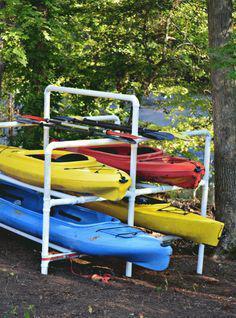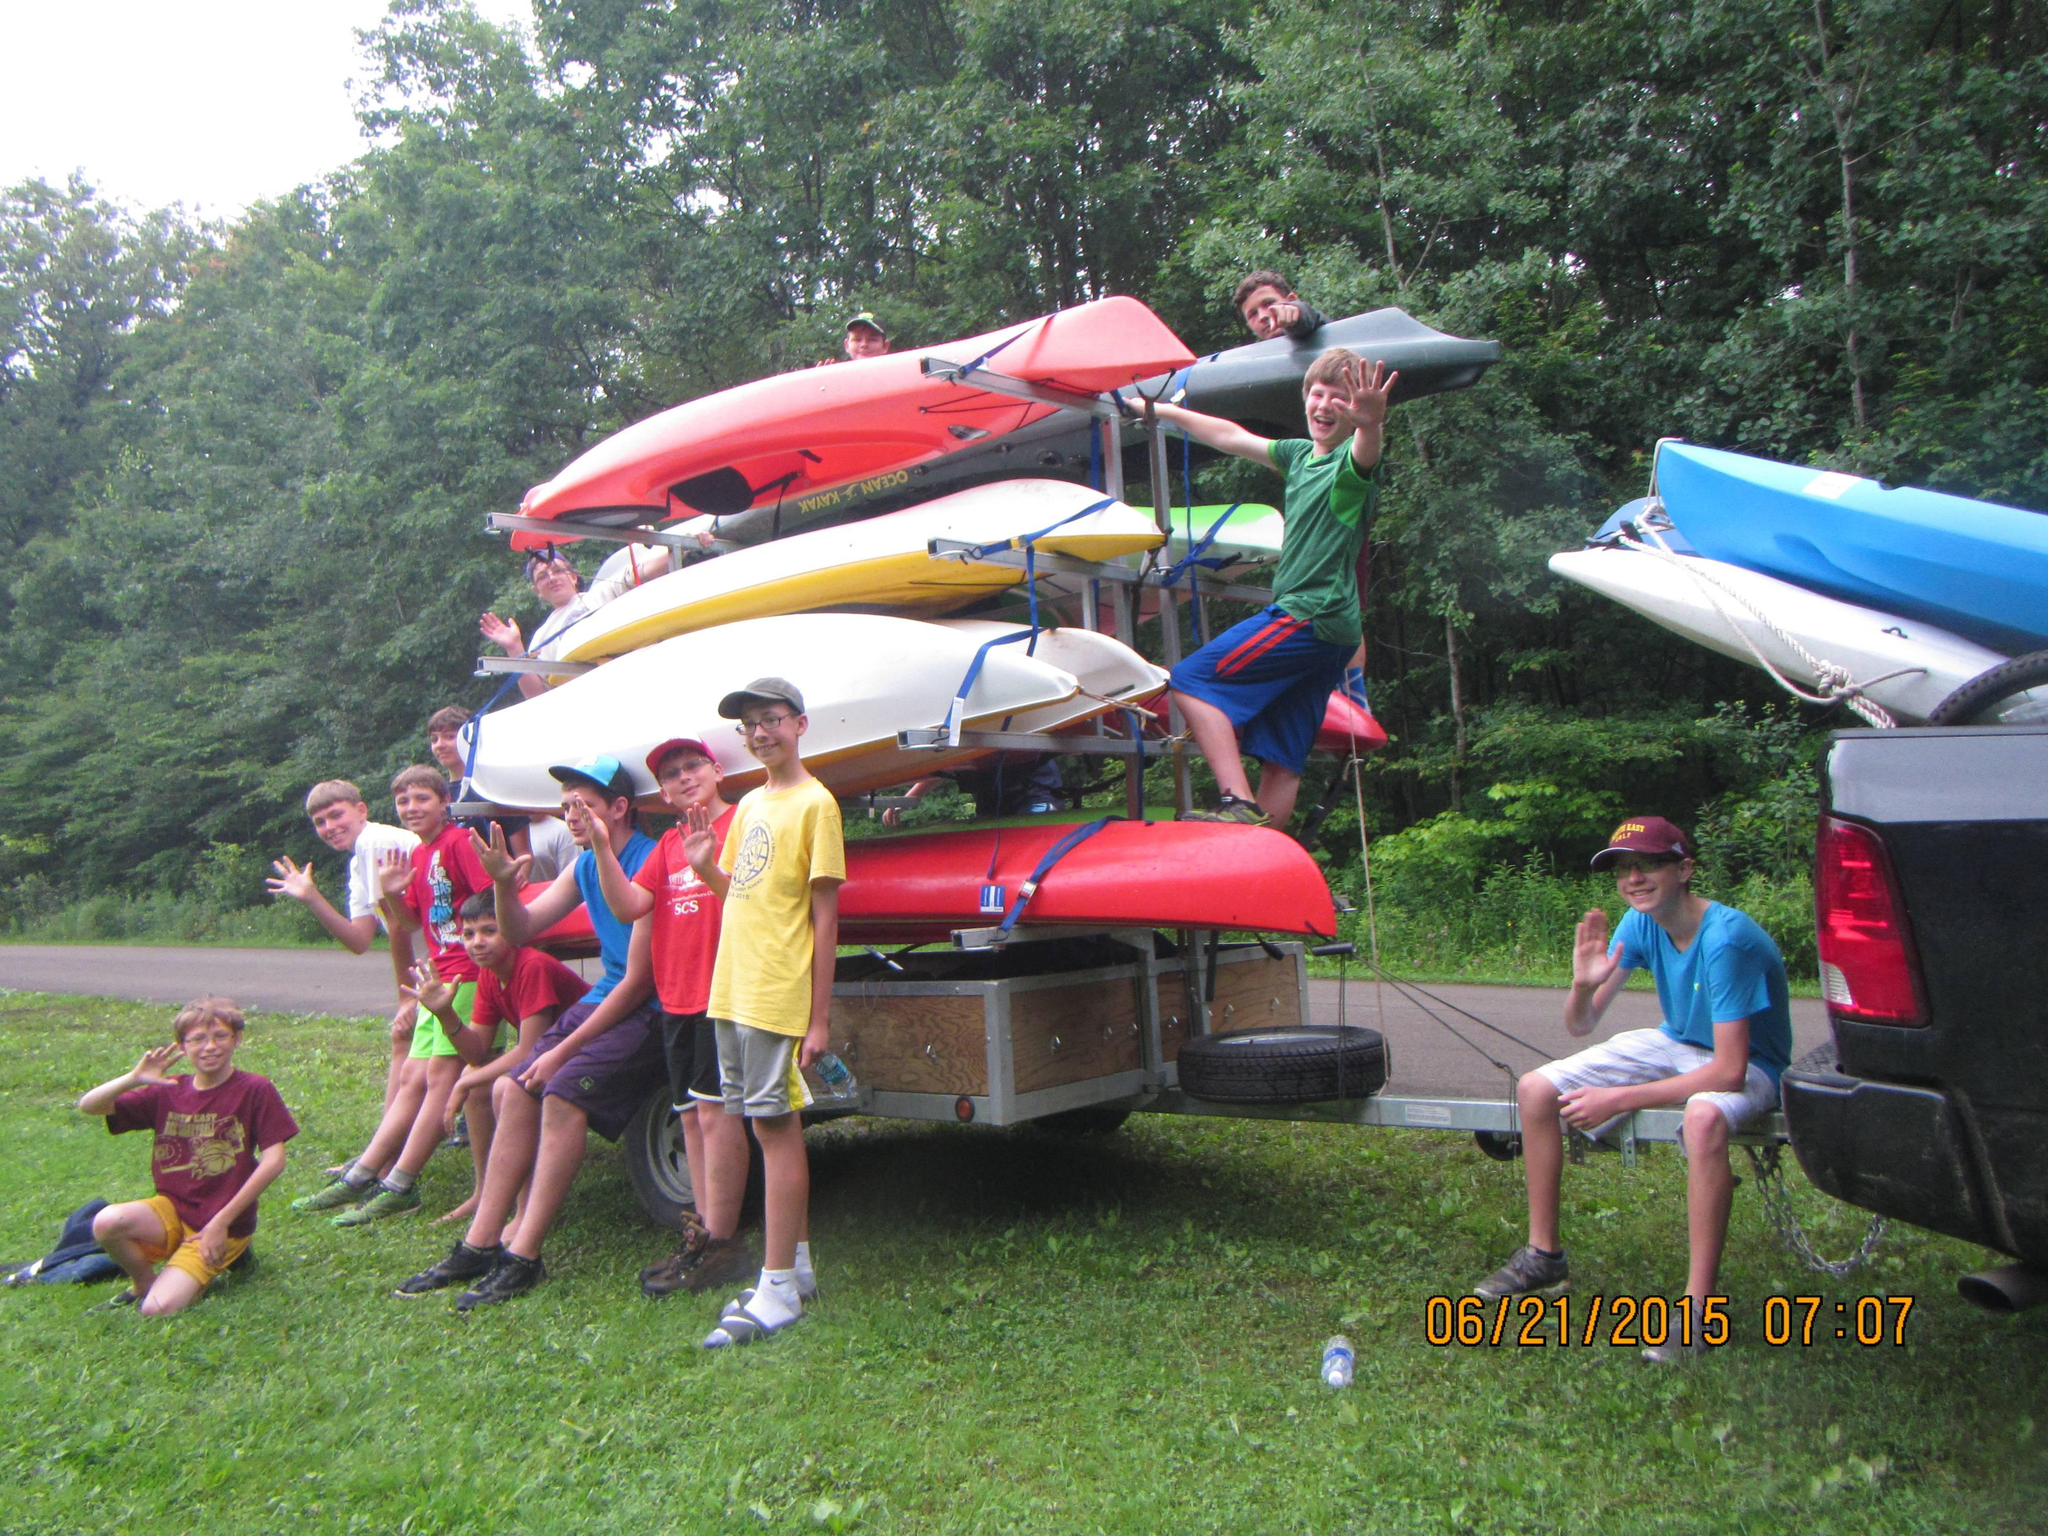The first image is the image on the left, the second image is the image on the right. Considering the images on both sides, is "In the image to the left, we have boats of yellow color, red color, and also blue color." valid? Answer yes or no. Yes. The first image is the image on the left, the second image is the image on the right. Considering the images on both sides, is "Each image includes a rack containing at least three boats in bright solid colors." valid? Answer yes or no. Yes. 